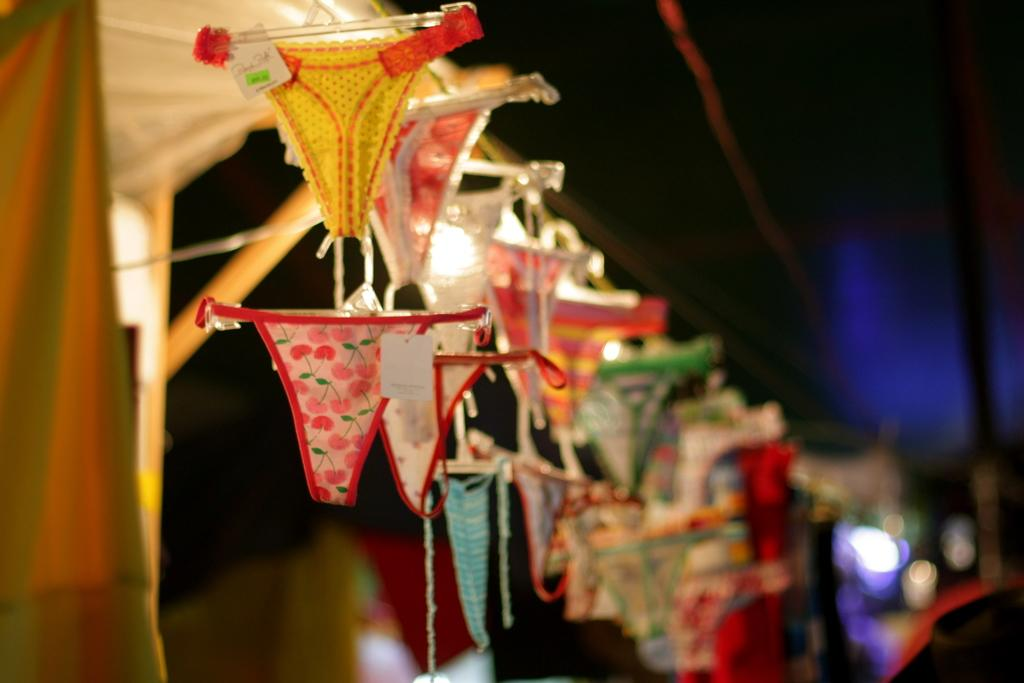What is hanging on the rod in the image? There are clothes on hangers in the image. How are the clothes attached to the rod? The hangers are attached to the rod. What can be seen on the left side of the image? There is a tent on the left side of the image. Can you describe the background of the image? The background of the image is blurry. Can you describe the smile on the crook's face in the image? There is no crook or smile present in the image. What is the taste of the tent on the left side of the image? Tents do not have a taste, as they are not edible objects. 